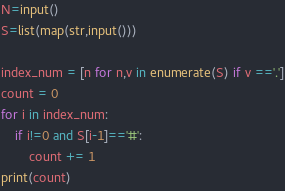<code> <loc_0><loc_0><loc_500><loc_500><_Python_>N=input()
S=list(map(str,input()))

index_num = [n for n,v in enumerate(S) if v =='.']
count = 0
for i in index_num:
    if i!=0 and S[i-1]=='#':
        count += 1
print(count)</code> 